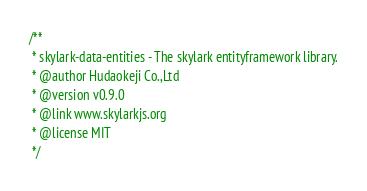Convert code to text. <code><loc_0><loc_0><loc_500><loc_500><_JavaScript_>/**
 * skylark-data-entities - The skylark entityframework library.
 * @author Hudaokeji Co.,Ltd
 * @version v0.9.0
 * @link www.skylarkjs.org
 * @license MIT
 */</code> 